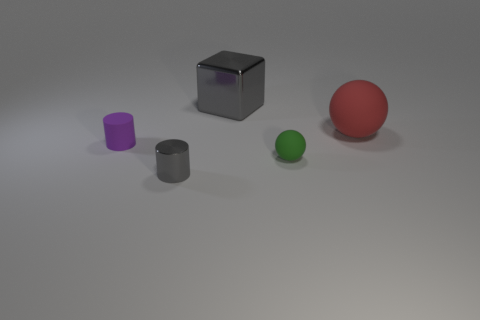Add 4 small purple balls. How many objects exist? 9 Subtract all balls. How many objects are left? 3 Add 1 tiny purple rubber objects. How many tiny purple rubber objects exist? 2 Subtract 0 cyan cylinders. How many objects are left? 5 Subtract all big gray matte cylinders. Subtract all cylinders. How many objects are left? 3 Add 4 tiny green balls. How many tiny green balls are left? 5 